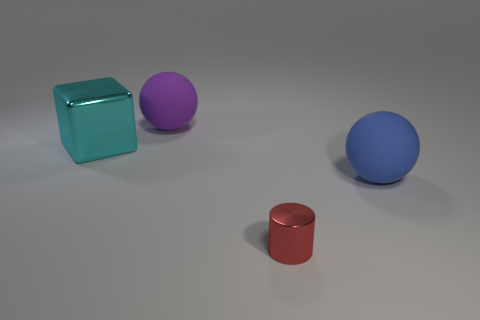Are there any tiny metal things?
Provide a succinct answer. Yes. Are the big block and the red cylinder that is to the right of the large metallic thing made of the same material?
Your answer should be very brief. Yes. What is the material of the blue object that is the same size as the metal cube?
Provide a succinct answer. Rubber. Is there a large blue sphere that has the same material as the purple ball?
Your answer should be compact. Yes. Is there a red metal object that is on the left side of the matte ball that is in front of the metal thing that is behind the red shiny thing?
Keep it short and to the point. Yes. There is a blue matte object that is the same size as the purple matte thing; what shape is it?
Make the answer very short. Sphere. There is a matte ball that is in front of the purple sphere; does it have the same size as the object in front of the blue ball?
Provide a short and direct response. No. What number of gray cylinders are there?
Provide a succinct answer. 0. What size is the rubber sphere to the right of the big ball to the left of the rubber ball in front of the cyan thing?
Your answer should be compact. Large. Is there any other thing that is the same size as the metallic cylinder?
Your answer should be compact. No. 